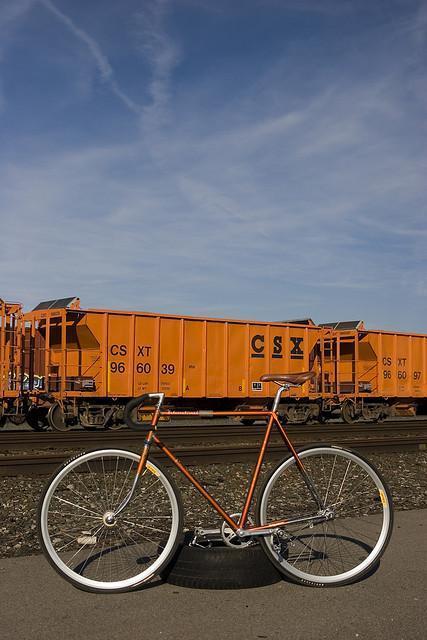How many methods of transportation are shown?
Give a very brief answer. 2. How many trains are visible?
Give a very brief answer. 1. How many people are wearing pink helmets?
Give a very brief answer. 0. 